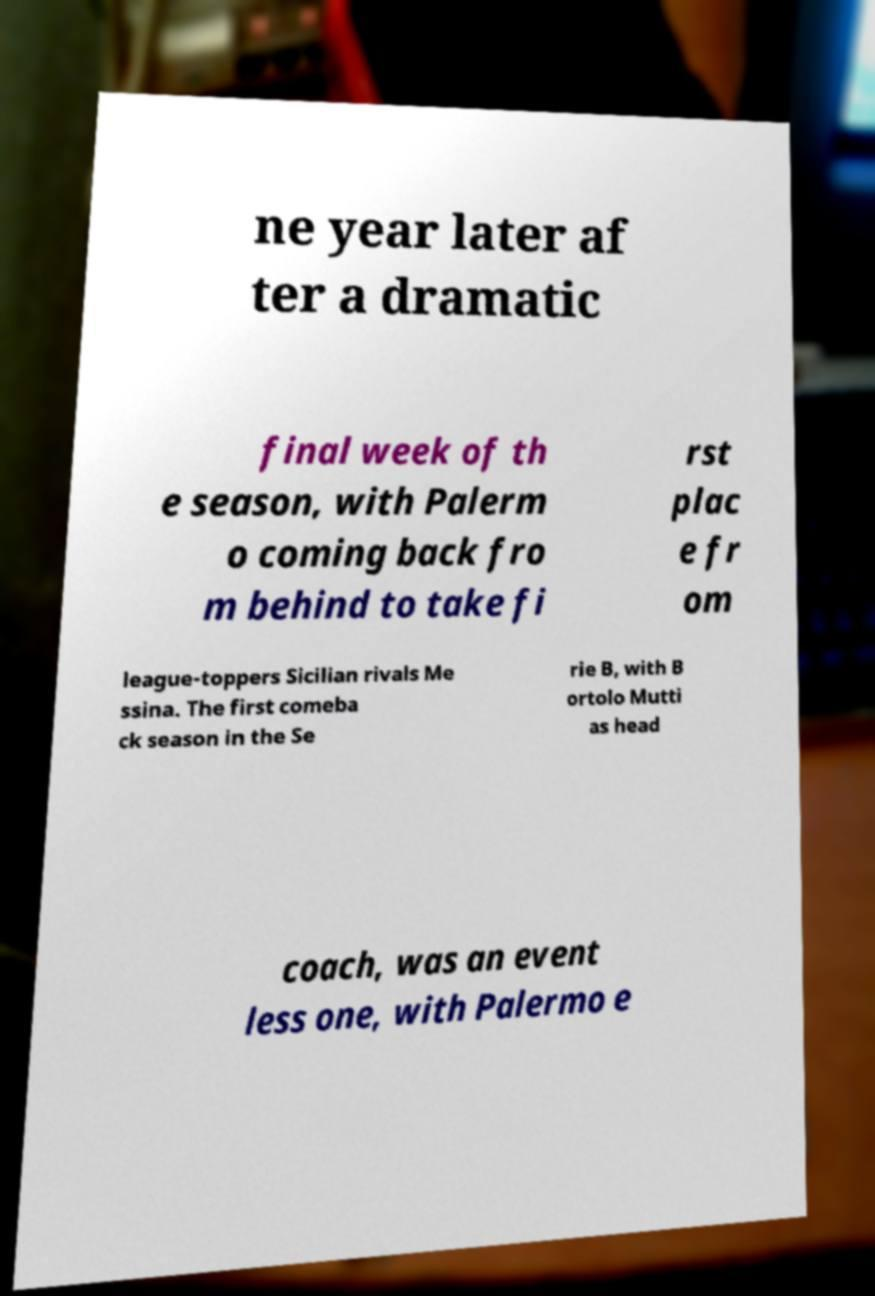Can you accurately transcribe the text from the provided image for me? ne year later af ter a dramatic final week of th e season, with Palerm o coming back fro m behind to take fi rst plac e fr om league-toppers Sicilian rivals Me ssina. The first comeba ck season in the Se rie B, with B ortolo Mutti as head coach, was an event less one, with Palermo e 